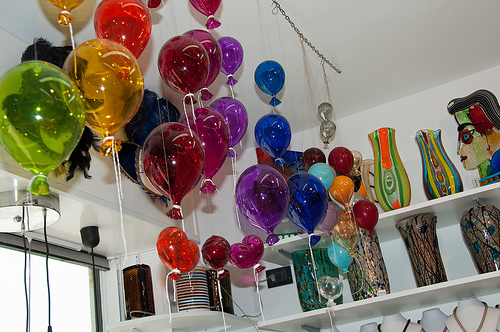<image>
Is there a green balloon next to the yellow balloon? Yes. The green balloon is positioned adjacent to the yellow balloon, located nearby in the same general area. Where is the metal chains in relation to the wall? Is it on the wall? Yes. Looking at the image, I can see the metal chains is positioned on top of the wall, with the wall providing support. Is the vase on the other vase? No. The vase is not positioned on the other vase. They may be near each other, but the vase is not supported by or resting on top of the other vase. 